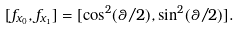<formula> <loc_0><loc_0><loc_500><loc_500>[ f _ { x _ { 0 } } , f _ { x _ { 1 } } ] = [ \cos ^ { 2 } ( \theta / 2 ) , \sin ^ { 2 } ( \theta / 2 ) ] .</formula> 